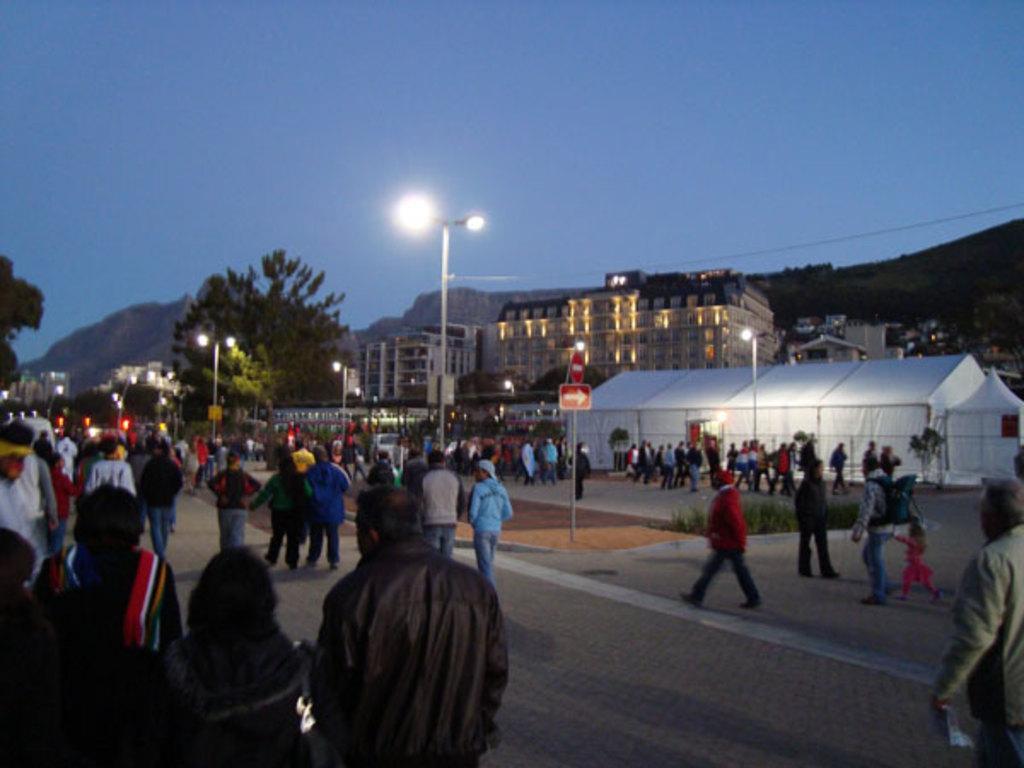Please provide a concise description of this image. This is looking like a busy street. There are many people on the street. In the background there are building,trees, hills. Beside the road there are street lights. This is a tent. 